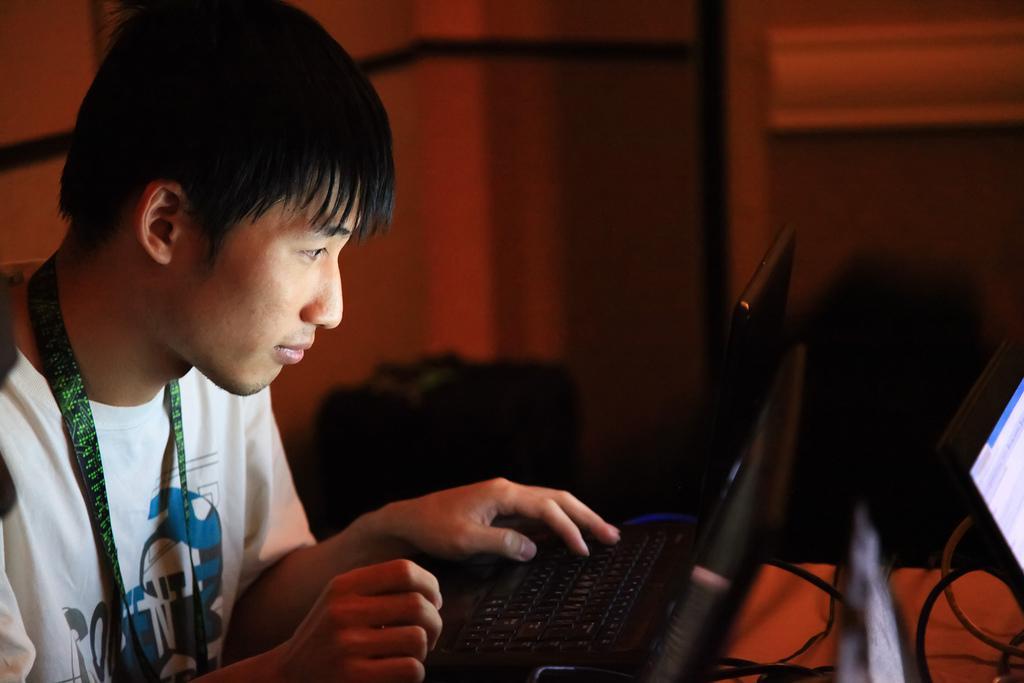Describe this image in one or two sentences. In this image we can see a person operating laptop and he wore a green color tag and white color shirt. 